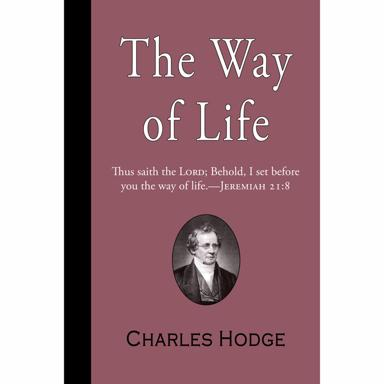Can you tell more about the specific theological contributions of Charles Hodge? Charles Hodge is best known for his staunch defense of Calvinist theology and his systematic exposition of Christian doctrine. His major works, such as 'Systematic Theology', present a comprehensive and rigorous analysis of biblical scripture, and have been used extensively in theological education. Hodge's thought focused heavily on the authority of the Bible and the importance of theological orthodoxy, influencing generations of theologians and clergy. 